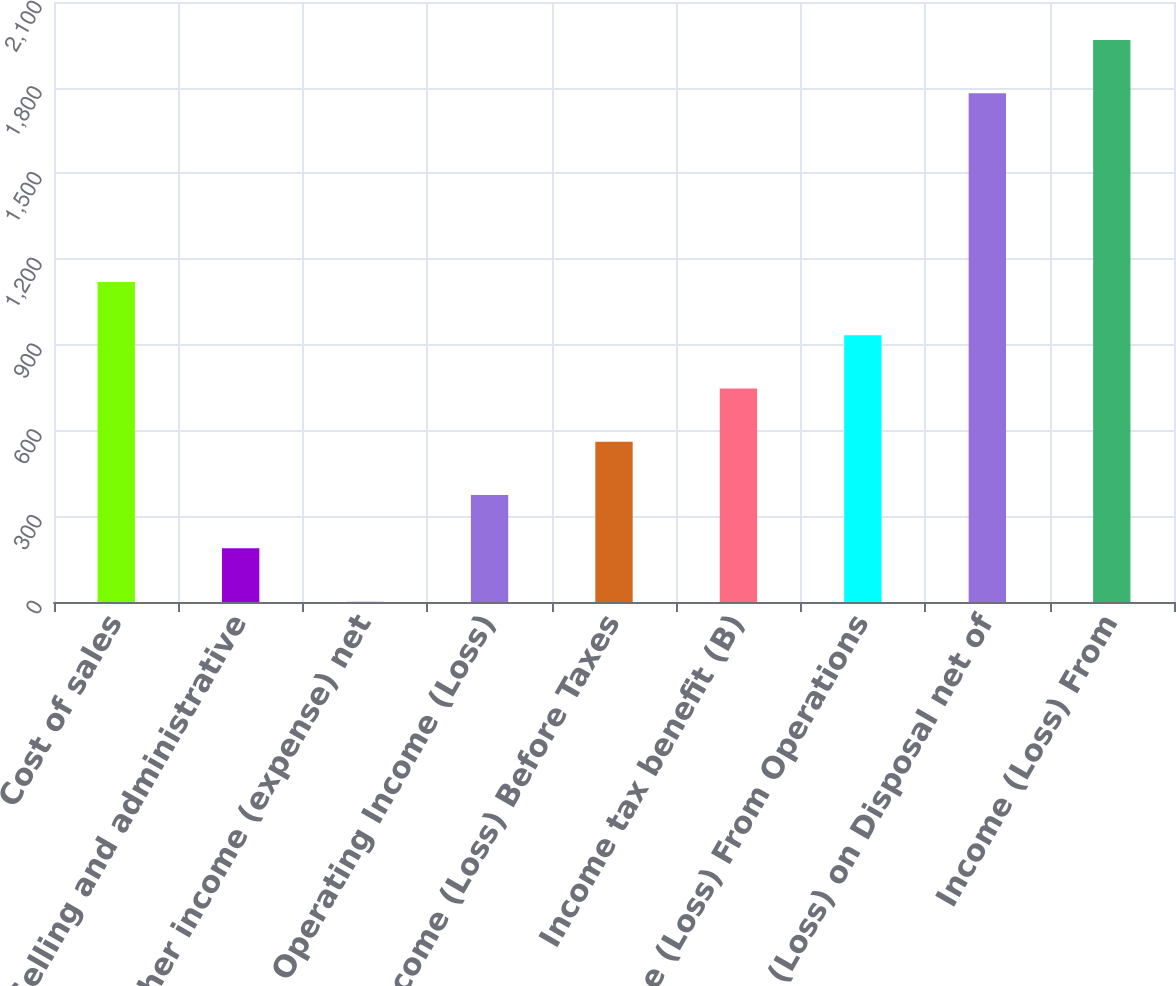Convert chart. <chart><loc_0><loc_0><loc_500><loc_500><bar_chart><fcel>Cost of sales<fcel>Selling and administrative<fcel>Other income (expense) net<fcel>Operating Income (Loss)<fcel>Income (Loss) Before Taxes<fcel>Income tax benefit (B)<fcel>Income (Loss) From Operations<fcel>Gain (Loss) on Disposal net of<fcel>Income (Loss) From<nl><fcel>1120.28<fcel>188.13<fcel>1.7<fcel>374.56<fcel>560.99<fcel>747.42<fcel>933.85<fcel>1780.5<fcel>1966.93<nl></chart> 